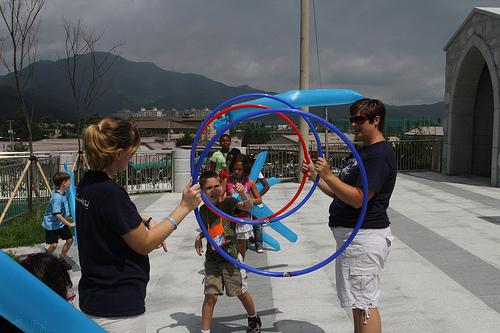<image>
Is the women to the left of the men? Yes. From this viewpoint, the women is positioned to the left side relative to the men. Where is the balloon in relation to the boy? Is it above the boy? Yes. The balloon is positioned above the boy in the vertical space, higher up in the scene. 